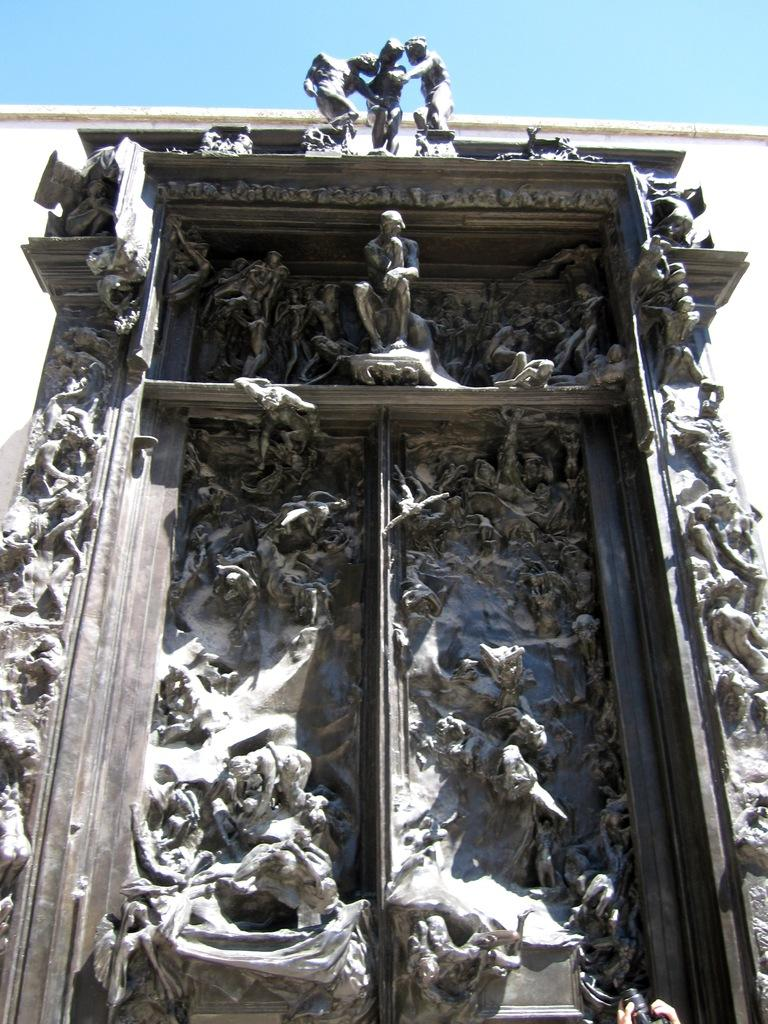What type of artwork can be seen on the wall in the image? There are sculptures of persons on the wall in the image. What is visible at the top of the image? The sky is visible at the top of the image. How many snails can be seen crawling on the sculptures in the image? There are no snails present in the image; it features sculptures of persons on the wall. What is the profit generated by the sculptures in the image? The image does not provide information about the profit generated by the sculptures, as it is not relevant to the visual content. 